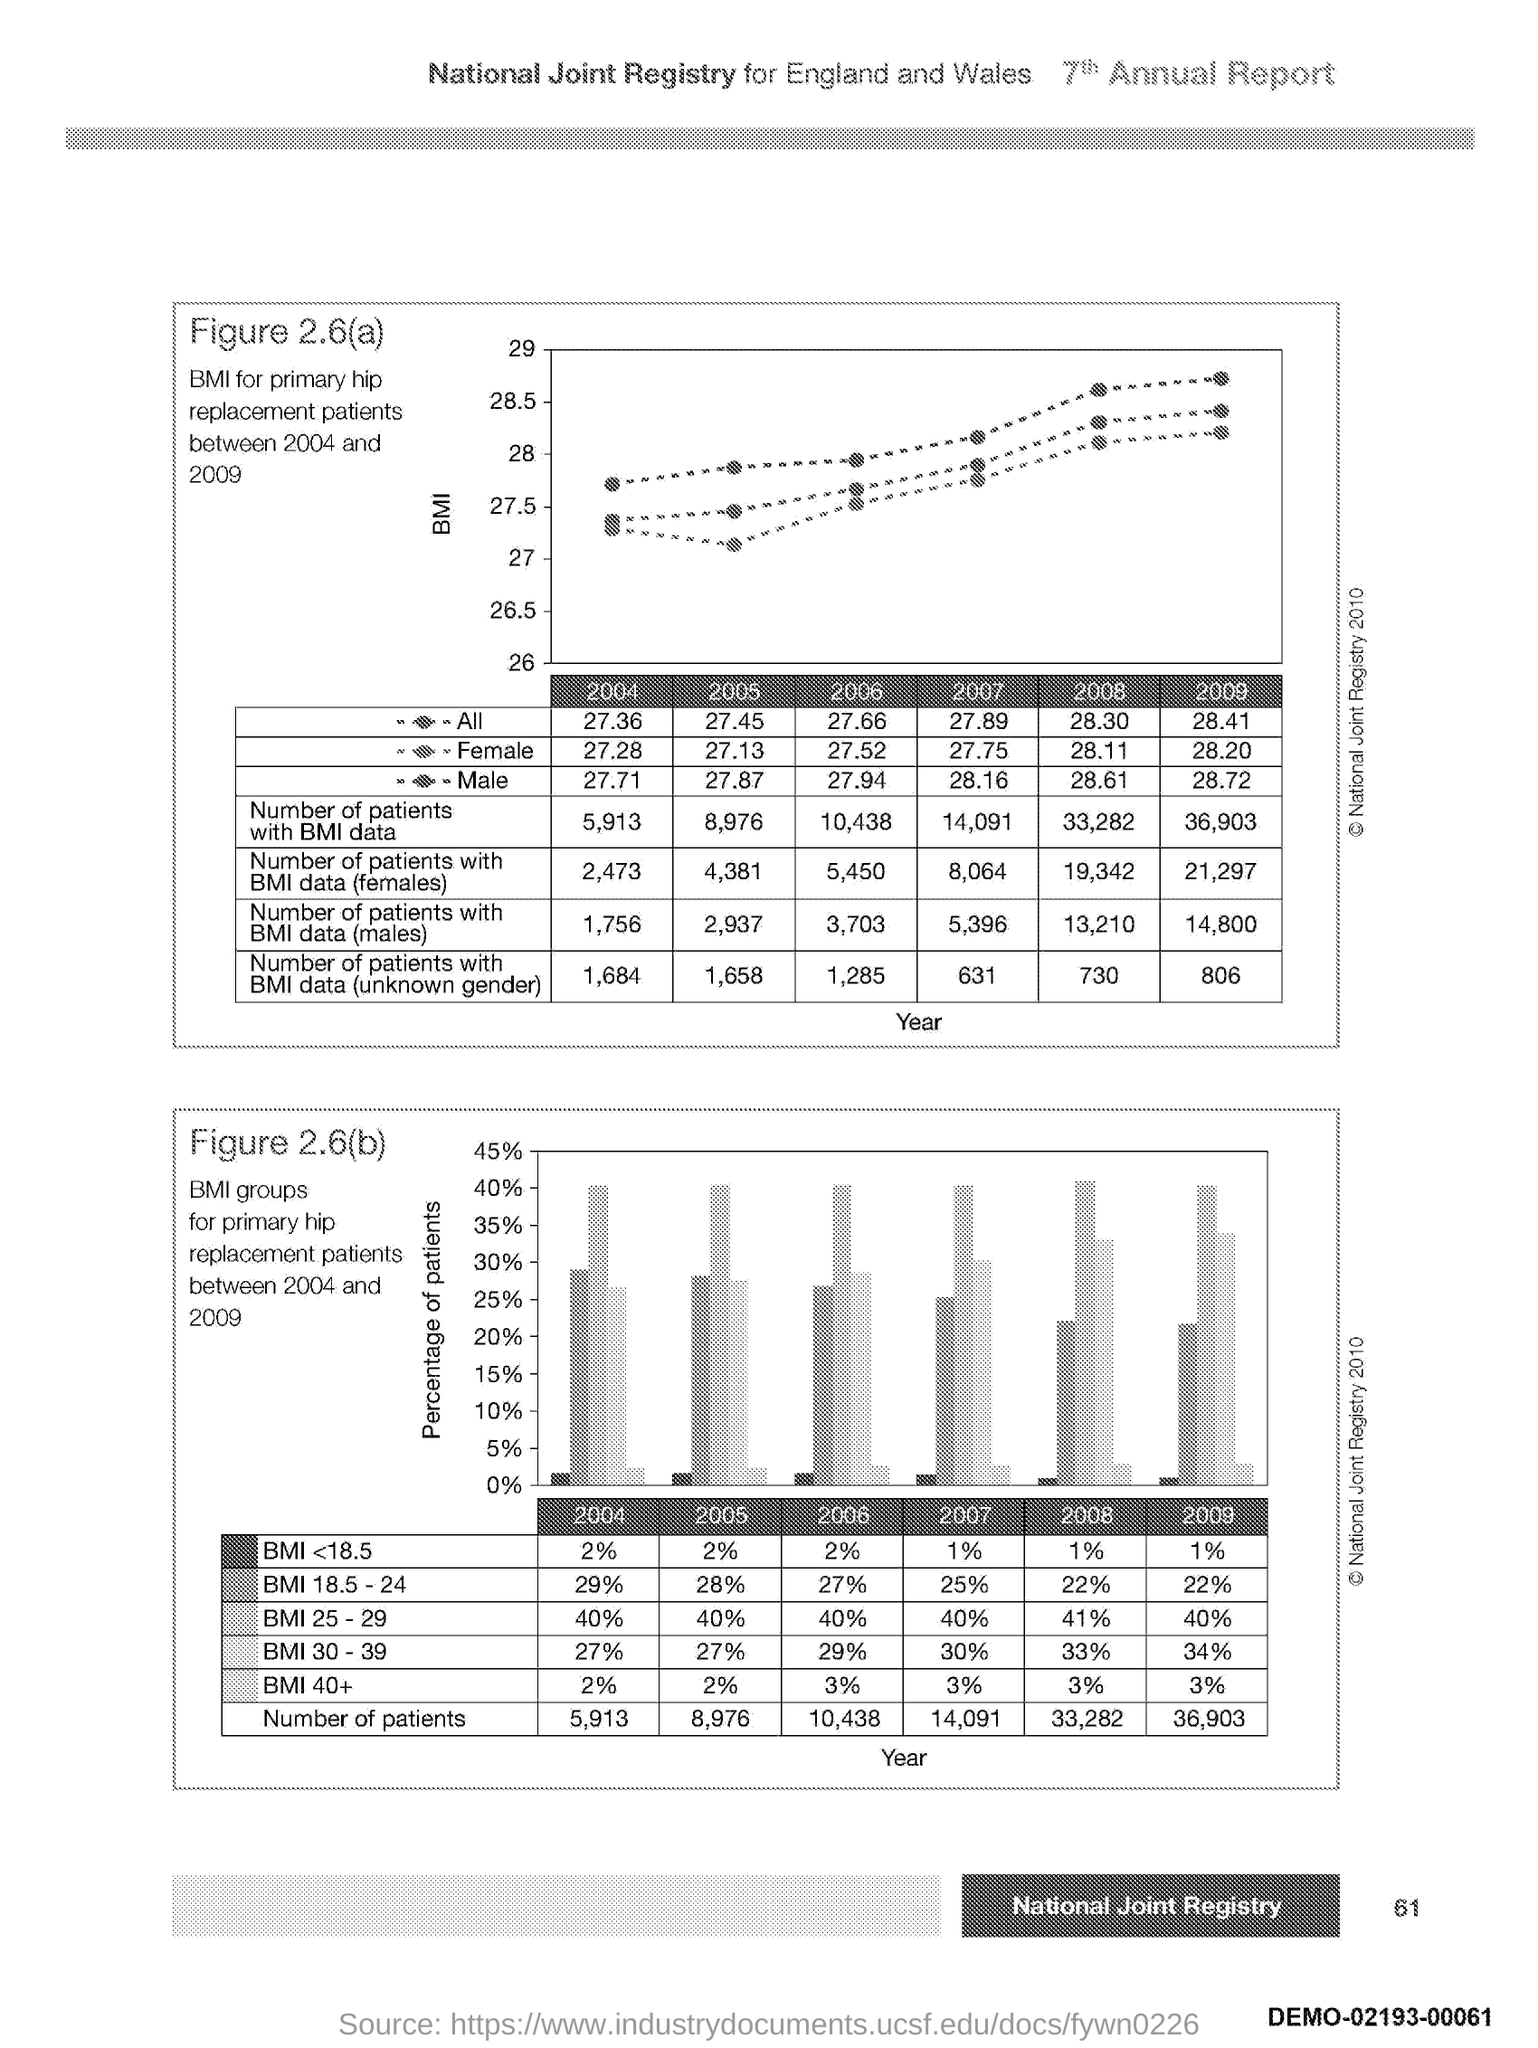What is plotted in the y-axis of first graph?
Offer a very short reply. Bmi. What is plotted in the y-axis of second graph?
Provide a succinct answer. Percentage of Patients. What is plotted in the x-axis of both graph?
Provide a short and direct response. Year. 